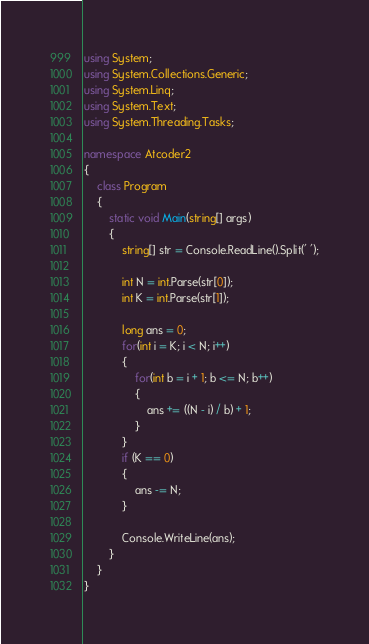<code> <loc_0><loc_0><loc_500><loc_500><_C#_>using System;
using System.Collections.Generic;
using System.Linq;
using System.Text;
using System.Threading.Tasks;

namespace Atcoder2
{
    class Program
    {
        static void Main(string[] args)
        {
            string[] str = Console.ReadLine().Split(' ');

            int N = int.Parse(str[0]);
            int K = int.Parse(str[1]);

            long ans = 0;
            for(int i = K; i < N; i++)
            {
                for(int b = i + 1; b <= N; b++)
                {
                    ans += ((N - i) / b) + 1;
                }
            }
            if (K == 0)
            {
                ans -= N;
            }

            Console.WriteLine(ans);
        }
    }
}
</code> 